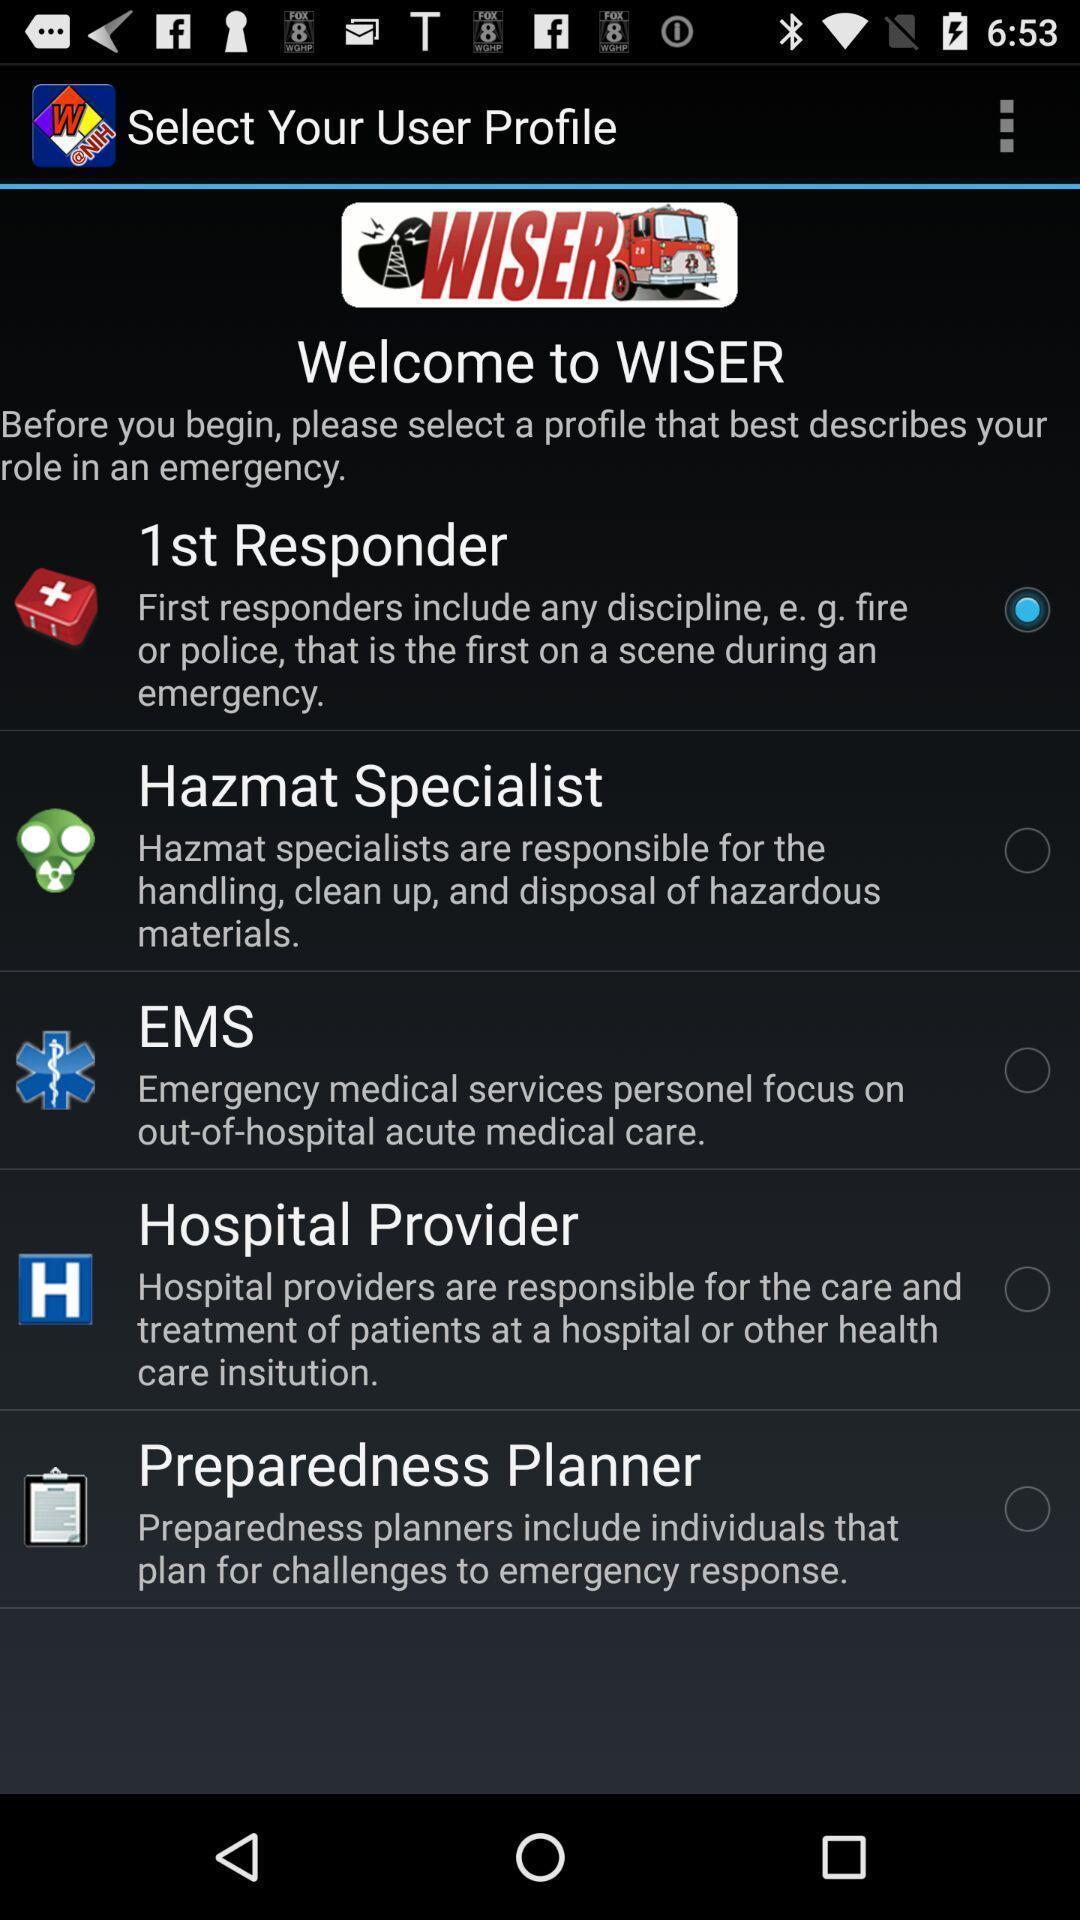What is the overall content of this screenshot? Screen displaying list of options in a welcome page. 